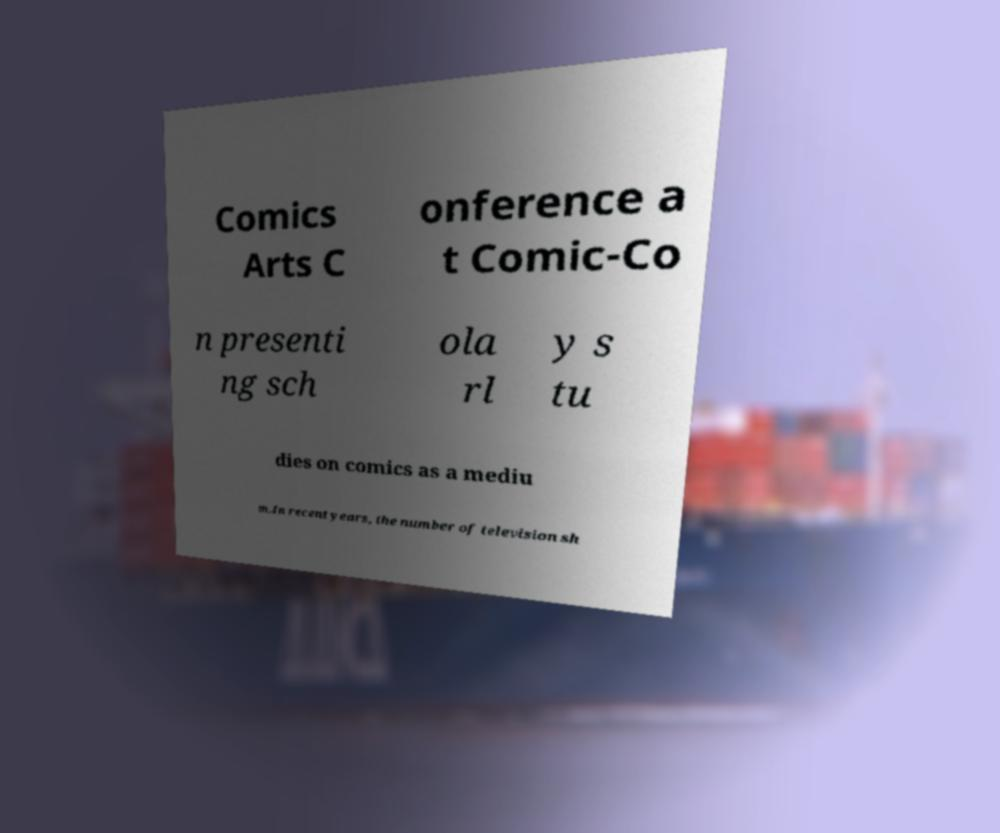I need the written content from this picture converted into text. Can you do that? Comics Arts C onference a t Comic-Co n presenti ng sch ola rl y s tu dies on comics as a mediu m.In recent years, the number of television sh 